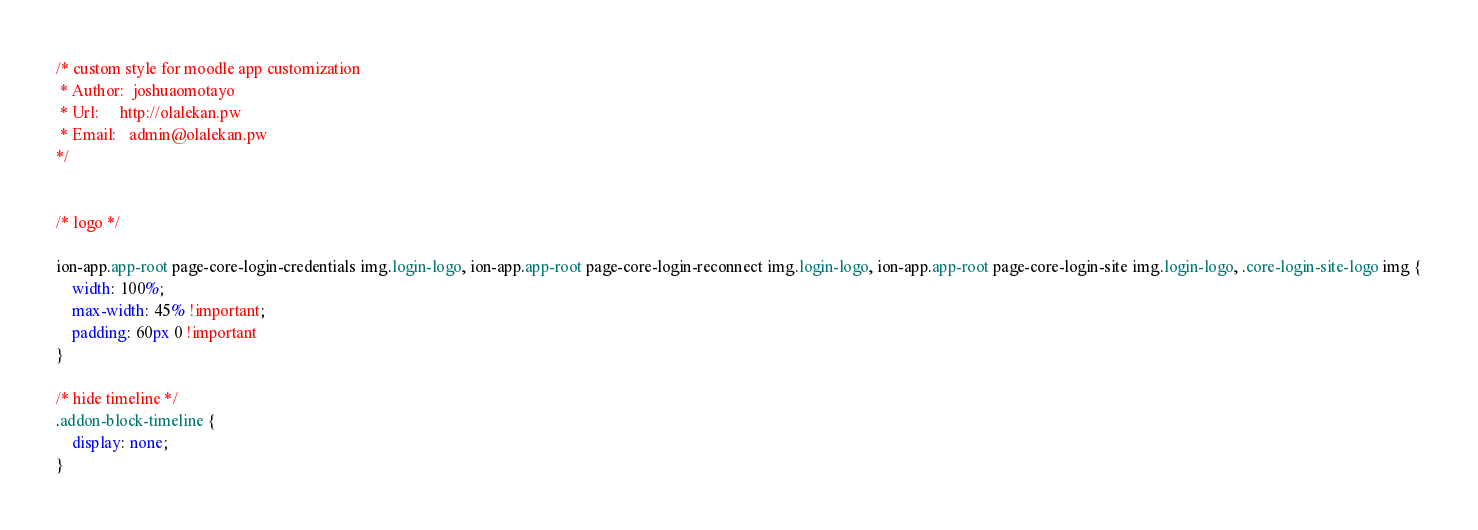<code> <loc_0><loc_0><loc_500><loc_500><_CSS_>/* custom style for moodle app customization 
 * Author:  joshuaomotayo
 * Url:     http://olalekan.pw
 * Email:   admin@olalekan.pw
*/


/* logo */

ion-app.app-root page-core-login-credentials img.login-logo, ion-app.app-root page-core-login-reconnect img.login-logo, ion-app.app-root page-core-login-site img.login-logo, .core-login-site-logo img {
    width: 100%;
    max-width: 45% !important;
    padding: 60px 0 !important
}

/* hide timeline */
.addon-block-timeline {
    display: none;
}
</code> 